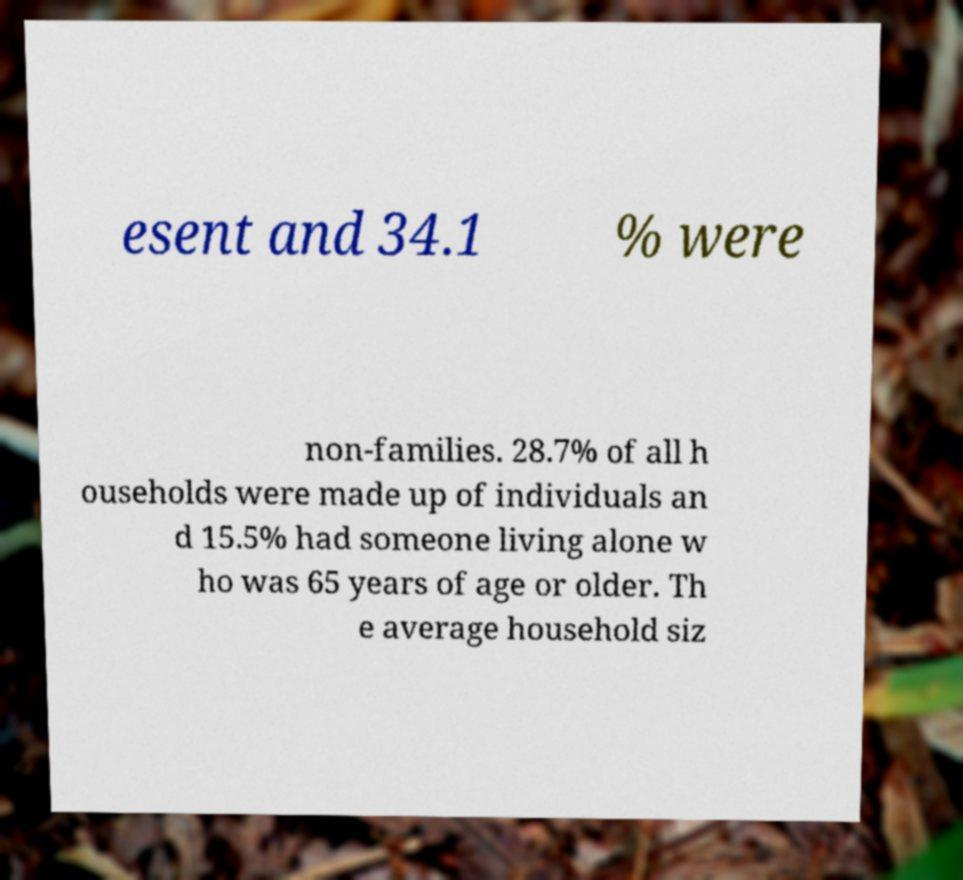Please identify and transcribe the text found in this image. esent and 34.1 % were non-families. 28.7% of all h ouseholds were made up of individuals an d 15.5% had someone living alone w ho was 65 years of age or older. Th e average household siz 